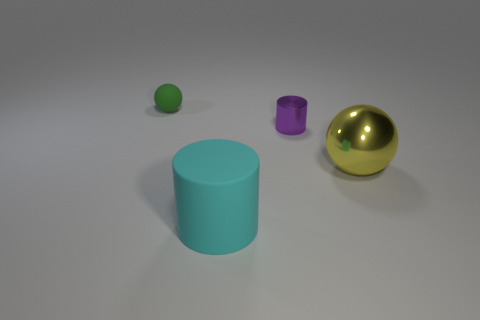Is the number of tiny blue metal blocks greater than the number of small purple things?
Your answer should be very brief. No. Do the large yellow ball and the tiny green object have the same material?
Offer a very short reply. No. Is the number of small rubber spheres in front of the purple cylinder the same as the number of red matte blocks?
Your answer should be compact. Yes. What number of large yellow spheres are made of the same material as the purple cylinder?
Offer a terse response. 1. Is the number of purple shiny cylinders less than the number of things?
Your answer should be very brief. Yes. What number of objects are on the right side of the yellow shiny sphere in front of the ball that is left of the big cyan object?
Provide a short and direct response. 0. There is a big yellow shiny thing; how many large objects are in front of it?
Provide a short and direct response. 1. There is another thing that is the same shape as the tiny green thing; what is its color?
Make the answer very short. Yellow. What is the object that is to the left of the purple cylinder and behind the large cyan cylinder made of?
Your answer should be compact. Rubber. Is the size of the cylinder that is to the left of the purple metal cylinder the same as the big yellow ball?
Provide a short and direct response. Yes. 